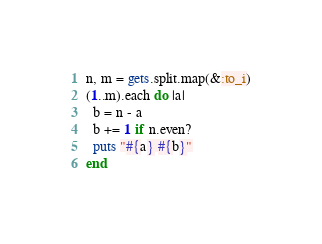<code> <loc_0><loc_0><loc_500><loc_500><_Ruby_>n, m = gets.split.map(&:to_i)
(1..m).each do |a|
  b = n - a
  b += 1 if n.even?
  puts "#{a} #{b}"
end
</code> 